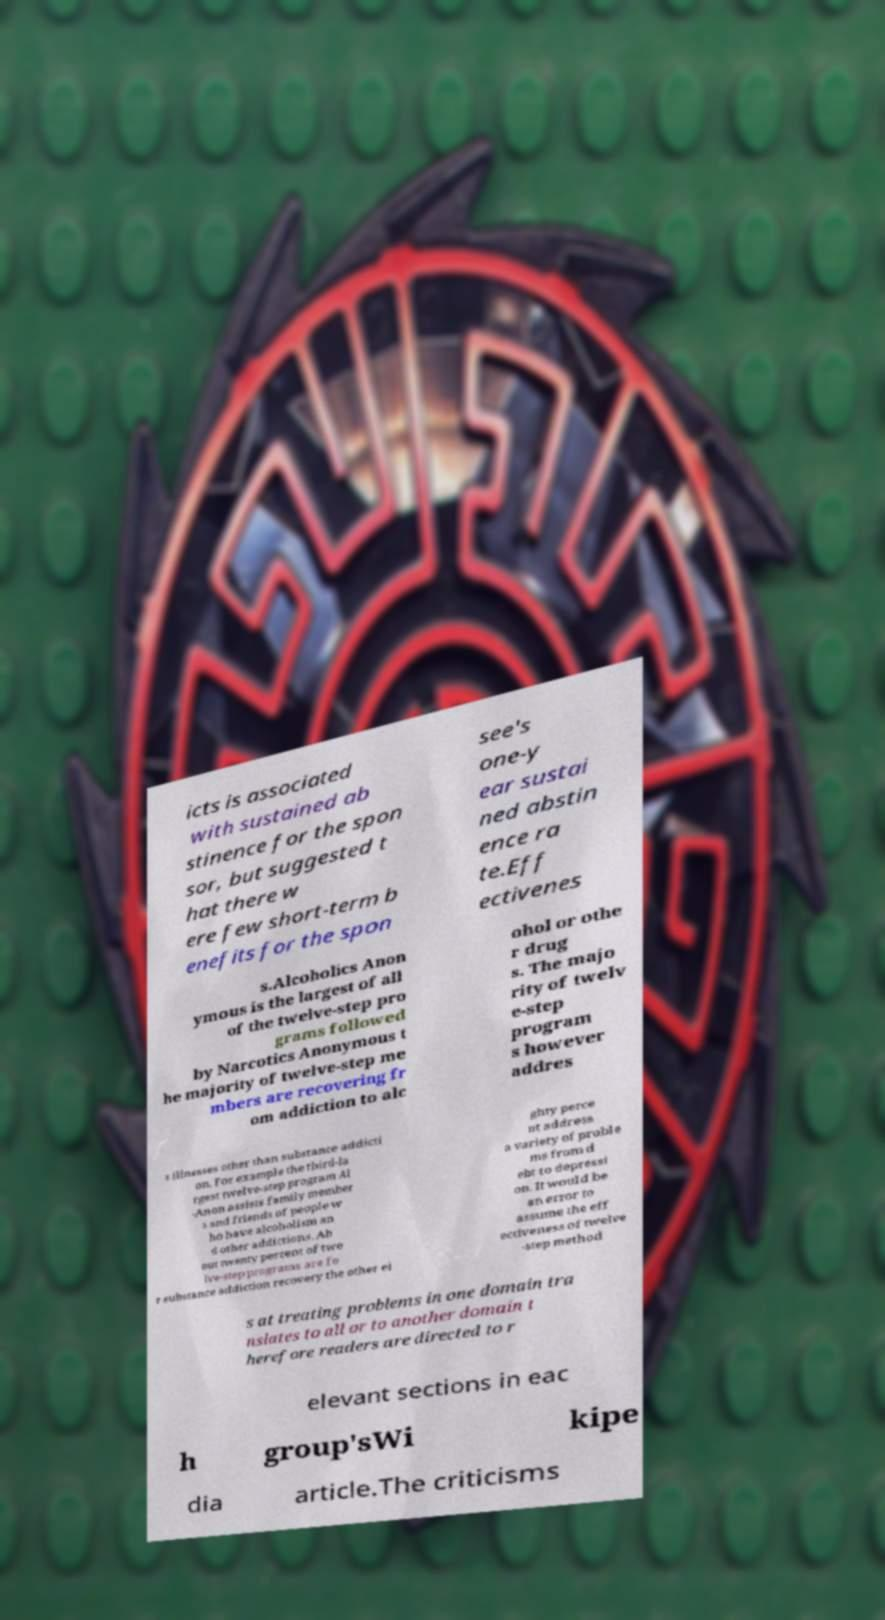Could you assist in decoding the text presented in this image and type it out clearly? icts is associated with sustained ab stinence for the spon sor, but suggested t hat there w ere few short-term b enefits for the spon see's one-y ear sustai ned abstin ence ra te.Eff ectivenes s.Alcoholics Anon ymous is the largest of all of the twelve-step pro grams followed by Narcotics Anonymous t he majority of twelve-step me mbers are recovering fr om addiction to alc ohol or othe r drug s. The majo rity of twelv e-step program s however addres s illnesses other than substance addicti on. For example the third-la rgest twelve-step program Al -Anon assists family member s and friends of people w ho have alcoholism an d other addictions. Ab out twenty percent of twe lve-step programs are fo r substance addiction recovery the other ei ghty perce nt address a variety of proble ms from d ebt to depressi on. It would be an error to assume the eff ectiveness of twelve -step method s at treating problems in one domain tra nslates to all or to another domain t herefore readers are directed to r elevant sections in eac h group'sWi kipe dia article.The criticisms 